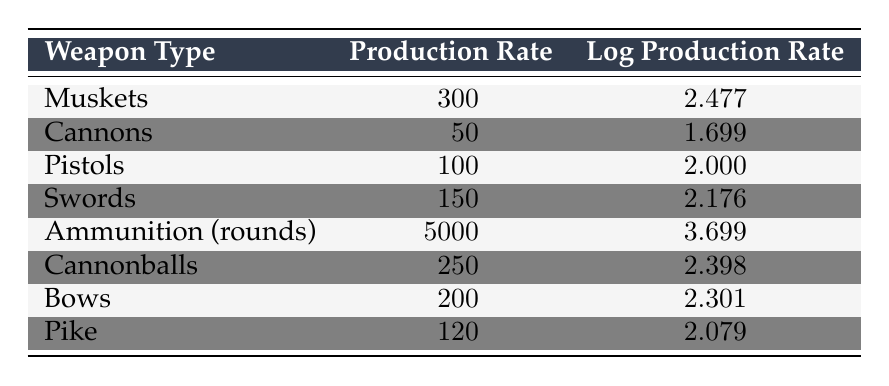What is the production rate for ammunition (rounds)? The table lists the production rate for ammunition (rounds) directly, which is specified as 5000.
Answer: 5000 Which weapon type has the highest log production rate? The log production rates for each weapon type are compared, and it is noted that the highest value of 3.699 corresponds to ammunition (rounds).
Answer: Ammunition (rounds) What is the difference between the production rates of muskets and pistols? The production rate for muskets is 300 and for pistols is 100. The difference is calculated as 300 - 100 = 200.
Answer: 200 Is the production rate of cannons greater than that of swords? The production rate for cannons is 50 and for swords is 150. Since 50 is not greater than 150, the answer is no.
Answer: No What is the average production rate of all weapons listed? To find the average, sum the production rates (300 + 50 + 100 + 150 + 5000 + 250 + 200 + 120 = 6120) and divide by the number of weapon types (8). The average is 6120 / 8 = 765.
Answer: 765 Is the log production rate for pike less than that for bows? The log production rate for pike is 2.079, and for bows, it is 2.301. Since 2.079 is less than 2.301, the answer is yes.
Answer: Yes Which weapon type has the lowest production rate, and what is that rate? The lowest production rate listed is for cannons, which has a production rate of 50, the minimum among all weapon types in the table.
Answer: Cannons, 50 What is the total production rate of all weapon types combined? The total production rate is calculated by adding together all the individual rates: 300 + 50 + 100 + 150 + 5000 + 250 + 200 + 120 = 6120.
Answer: 6120 